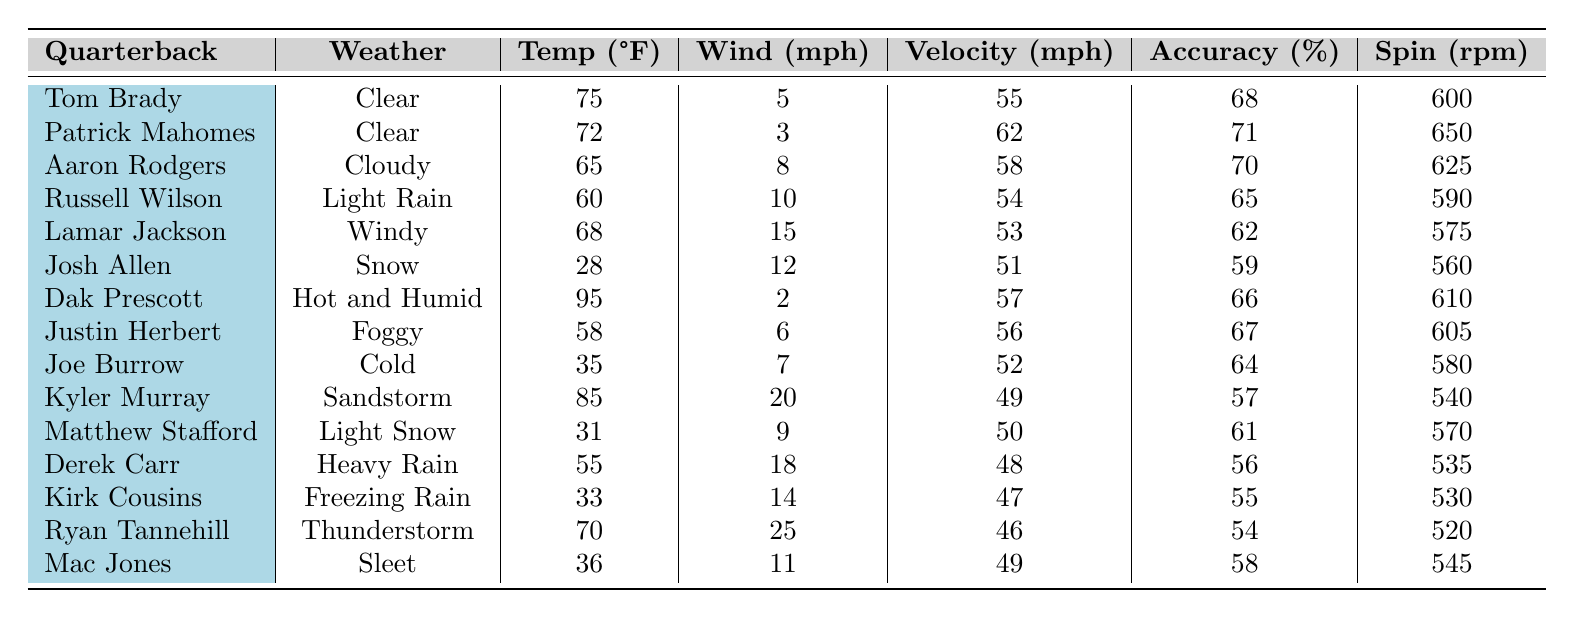What is the throwing velocity of Patrick Mahomes in clear weather? The table shows that Patrick Mahomes has a throwing velocity of 62 mph under clear weather conditions.
Answer: 62 mph In which weather condition does Tom Brady throw the fastest? Tom Brady throws the fastest with a velocity of 55 mph and the weather condition is clear. However, he also has the same speed in other conditions, meaning he throws at the same speed in clear weather.
Answer: Clear What is the average accuracy percentage of quarterbacks throwing in foggy and light rain conditions? From the table, Justin Herbert in foggy conditions has an accuracy of 67%, while Russell Wilson in light rain has an accuracy of 65%. The average is (67 + 65) / 2 = 66%.
Answer: 66% Which quarterback has the highest throwing velocity in snowy conditions? Josh Allen has the highest throwing velocity in snowy conditions, which is 51 mph. There are no other quarterbacks listed with a higher velocity in that condition.
Answer: 51 mph Is it true that Kirk Cousins throws faster in freezing rain than Ryan Tannehill does in a thunderstorm? No, Kirk Cousins throws at 47 mph in freezing rain, while Ryan Tannehill has a throwing velocity of 46 mph in a thunderstorm; thus, Kirk Cousins is actually faster.
Answer: No What is the difference in throwing velocity between Lamar Jackson in windy conditions and Josh Allen in snow conditions? Lamar Jackson has a throwing velocity of 53 mph in windy conditions, while Josh Allen throws at 51 mph in snow conditions. The difference is 53 - 51 = 2 mph.
Answer: 2 mph Which quarterback has the highest ball spin rate, and what is it? Patrick Mahomes has the highest ball spin rate at 650 rpm according to the data in the table.
Answer: 650 rpm What is the median throwing velocity of all quarterbacks listed? To find the median, first list the throwing velocities in ascending order: 46, 47, 48, 49, 49, 50, 51, 52, 53, 54, 55, 56, 57, 58, 62. There are 15 values, so the median is the 8th value, which is 52 mph.
Answer: 52 mph Which quarterback has the lowest accuracy percentage and what is it? Derek Carr has the lowest accuracy percentage at 56% when throwing in heavy rain conditions.
Answer: 56% How do throwing velocities compare between quarterbacks in clear weather and those in adverse conditions? In clear weather, the average velocity is (55 + 62) / 2 = 58.5 mph for Tom Brady and Patrick Mahomes. In adverse conditions (such as rain, snow, or windy), the average drops significantly, averaging closer to the lower 50s mph among most quarterbacks.
Answer: Clear weather velocities are generally higher 